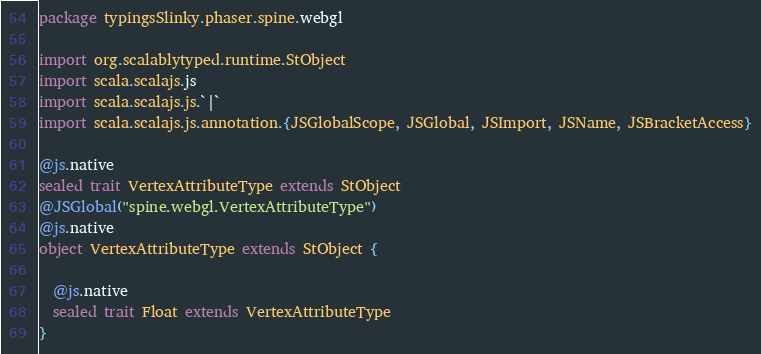Convert code to text. <code><loc_0><loc_0><loc_500><loc_500><_Scala_>package typingsSlinky.phaser.spine.webgl

import org.scalablytyped.runtime.StObject
import scala.scalajs.js
import scala.scalajs.js.`|`
import scala.scalajs.js.annotation.{JSGlobalScope, JSGlobal, JSImport, JSName, JSBracketAccess}

@js.native
sealed trait VertexAttributeType extends StObject
@JSGlobal("spine.webgl.VertexAttributeType")
@js.native
object VertexAttributeType extends StObject {
  
  @js.native
  sealed trait Float extends VertexAttributeType
}
</code> 